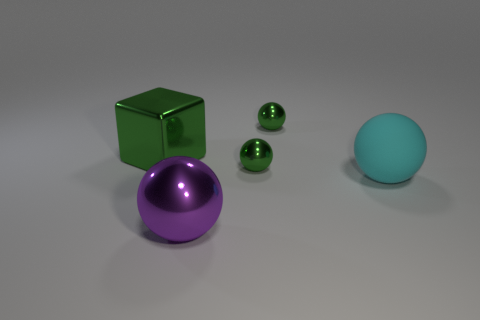Are there any other things that have the same material as the cyan sphere?
Keep it short and to the point. No. Does the big object that is to the right of the purple object have the same shape as the large thing that is in front of the large cyan ball?
Offer a terse response. Yes. What number of blocks are big metallic things or tiny things?
Keep it short and to the point. 1. Is the number of big metal spheres right of the purple metallic object less than the number of tiny gray rubber balls?
Offer a terse response. No. How many other things are there of the same material as the cyan sphere?
Keep it short and to the point. 0. Do the metal block and the purple ball have the same size?
Your response must be concise. Yes. What number of objects are either objects behind the large purple metal thing or tiny green balls?
Provide a succinct answer. 4. There is a block on the left side of the big object that is in front of the cyan ball; what is it made of?
Provide a short and direct response. Metal. Are there any other shiny objects that have the same shape as the purple metallic object?
Your answer should be compact. Yes. There is a green metal cube; is its size the same as the purple shiny ball right of the big green shiny block?
Keep it short and to the point. Yes. 